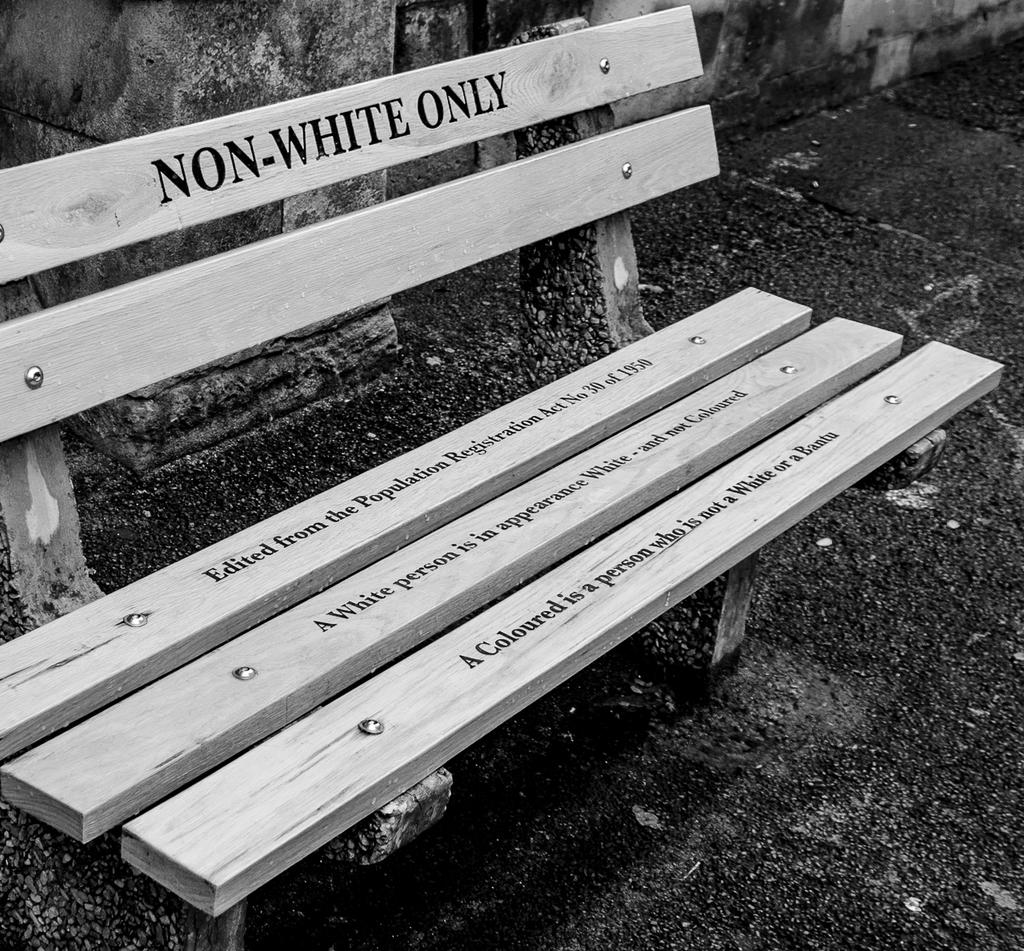What type of furniture is located on the left side of the image? There is a wooden bench on the left side of the image. What is written or engraved on the wooden bench? There are texts on the wooden bench. What can be seen in the background of the image? There is a wall in the background of the image. What shape is the rake in the image? There is no rake present in the image. How many cards are visible on the wooden bench? There are no cards visible on the wooden bench; only texts are present. 